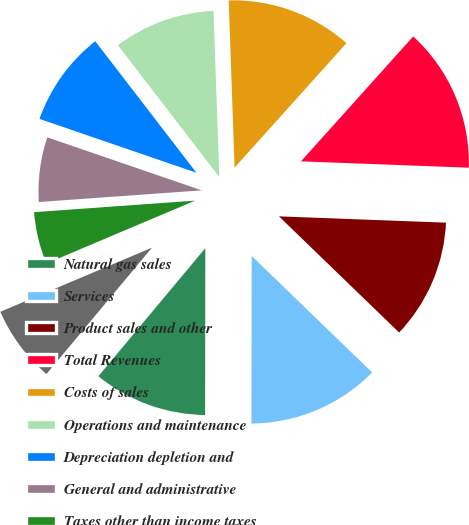Convert chart to OTSL. <chart><loc_0><loc_0><loc_500><loc_500><pie_chart><fcel>Natural gas sales<fcel>Services<fcel>Product sales and other<fcel>Total Revenues<fcel>Costs of sales<fcel>Operations and maintenance<fcel>Depreciation depletion and<fcel>General and administrative<fcel>Taxes other than income taxes<fcel>Loss (gain) on impairments and<nl><fcel>11.05%<fcel>12.79%<fcel>11.63%<fcel>13.95%<fcel>12.21%<fcel>9.88%<fcel>9.3%<fcel>6.4%<fcel>5.23%<fcel>7.56%<nl></chart> 